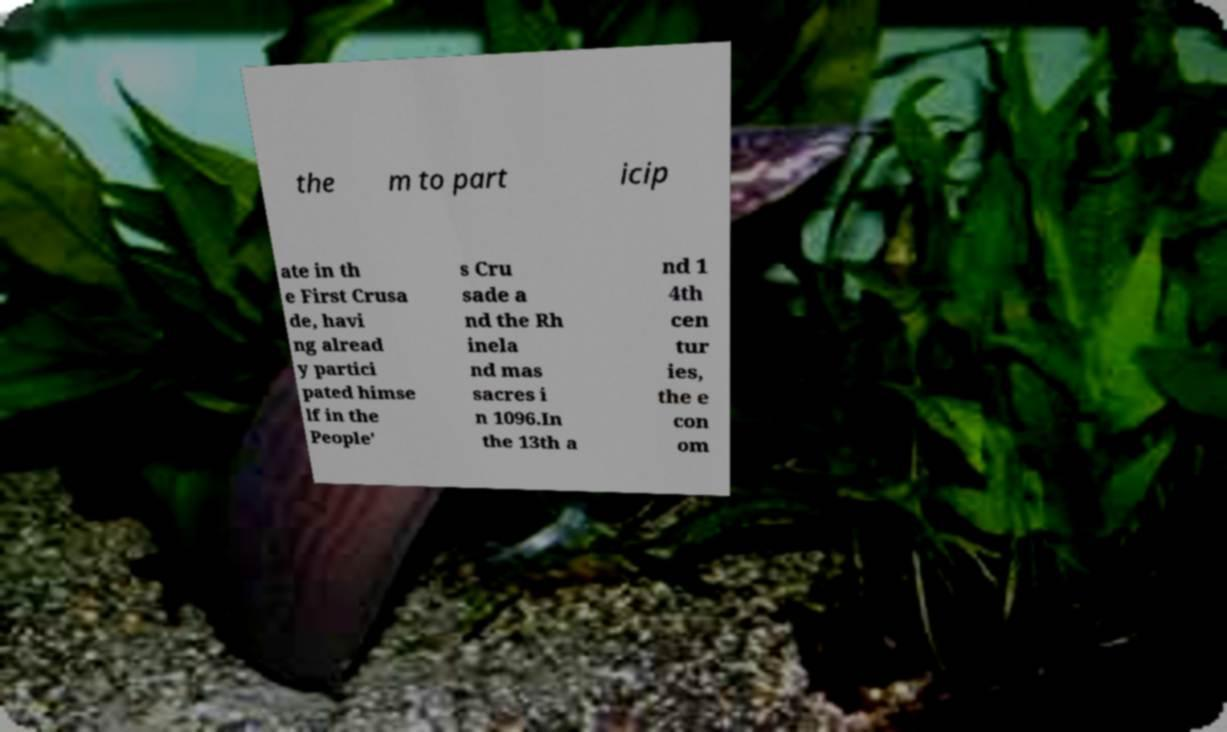There's text embedded in this image that I need extracted. Can you transcribe it verbatim? the m to part icip ate in th e First Crusa de, havi ng alread y partici pated himse lf in the People' s Cru sade a nd the Rh inela nd mas sacres i n 1096.In the 13th a nd 1 4th cen tur ies, the e con om 